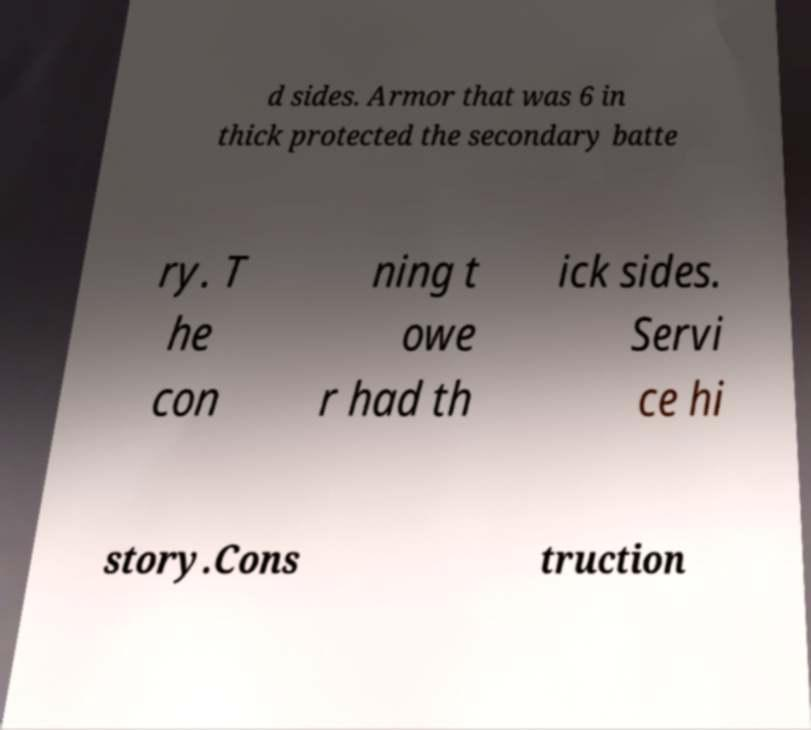I need the written content from this picture converted into text. Can you do that? d sides. Armor that was 6 in thick protected the secondary batte ry. T he con ning t owe r had th ick sides. Servi ce hi story.Cons truction 